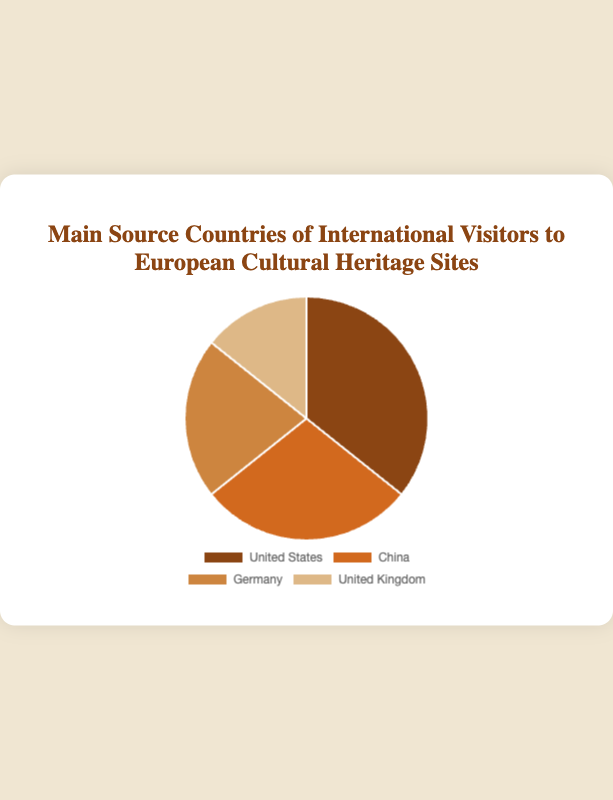What is the main source country of international visitors to European cultural heritage sites? The country that contributes the largest percentage of visitors is the main source country. According to the chart, the United States contributes 25% of the visitors.
Answer: United States Which two countries together contribute to 50% of the international visitors? To find which two countries together make up 50%, we start by adding the percentages. The United States contributes 25%, and China contributes 20%. Together, they make up 45%. Adding Germany’s 15% would exceed 50%. Instead, adding the United Kingdom's 10% to the United States' 25% gives 35%. Thus, the correct combination is the United States (25%) and China (20%), adding up to 45%. However, since the sum must be exactly 50%, we do so step-wise: United States 25% and China 20% add to 45%, adding Germany's 15% makes it over, so rethinking backward, 50-25 = 25, then China and United Kingdom share of 30%, so United States and United Kingdom 35%.checking backward US 25%, China 20%=45%
Answer: United States and China Which country has the least number of international visitors coming to European cultural heritage sites? The country with the smallest percentage of visitors is the one contributing the lowest number on the chart. The United Kingdom has the smallest percentage at 10%.
Answer: United Kingdom How much greater is the percentage of visitors from the United States compared to the United Kingdom? We find the difference in the percentage of visitors between the United States and the United Kingdom. The difference is 25% - 10% = 15%.
Answer: 15% What is the combined percentage of visitors from Germany and the United Kingdom? We find the sum of the percentages of visitors from Germany and the United Kingdom. Germany contributes 15%, and the United Kingdom contributes 10%. The combined percentage is 15% + 10% = 25%.
Answer: 25% Which two countries combined exceed the percentage of visitors from China? To find two countries whose combined percentage is higher than China's 20%, we try combinations. The United States (25%) alone is already higher than China. So, we check smaller combinations, like Germany (15%) and United Kingdom (10%), totaling 15% + 10% = 25%, which also exceeds 20%.
Answer: Germany and United Kingdom What color represents the segment with the second-highest percentage of visitors? The second-highest segment is China with 20%. According to the chart, China is represented by the color orange.
Answer: Orange Compare the total percentage of visitors from China and Germany with that from the United States. Which one is greater, and by how much? First, we sum the percentages of China (20%) and Germany (15%): 20% + 15% = 35%. The United States alone contributes 25%. Comparing 35% and 25%, 35% is greater by 35% - 25% = 10%.
Answer: China and Germany by 10% How does the percentage of visitors from the United States compare to the percentages from Germany and the United Kingdom combined? The United States has 25% of visitors. Germany and the United Kingdom together have 15% and 10%, respectively. Adding those gives us 15% + 10% = 25%. Comparing both, they are equal.
Answer: Equal If the percentage of visitors from the United Kingdom increased by 5%, how would its new percentage compare to Germany's current percentage? The current percentage of visitors from the United Kingdom is 10%. If it increases by 5%, it becomes 10% + 5% = 15%. Germany's current percentage is also 15%. Thus, they would be equal.
Answer: Equal 